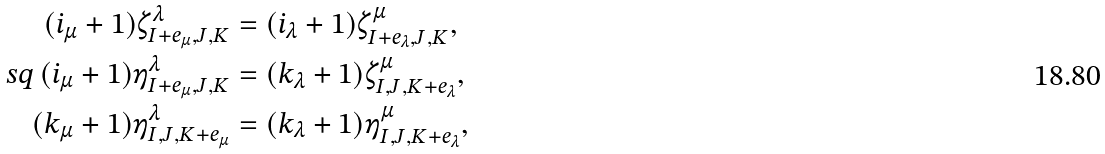<formula> <loc_0><loc_0><loc_500><loc_500>( i _ { \mu } + 1 ) \zeta ^ { \lambda } _ { I + e _ { \mu } , J , K } & = ( i _ { \lambda } + 1 ) \zeta ^ { \mu } _ { I + e _ { \lambda } , J , K } , \\ \ s q \, ( i _ { \mu } + 1 ) \eta ^ { \lambda } _ { I + e _ { \mu } , J , K } & = ( k _ { \lambda } + 1 ) \zeta ^ { \mu } _ { I , J , K + e _ { \lambda } } , \\ ( k _ { \mu } + 1 ) \eta ^ { \lambda } _ { I , J , K + e _ { \mu } } & = ( k _ { \lambda } + 1 ) \eta ^ { \mu } _ { I , J , K + e _ { \lambda } } ,</formula> 